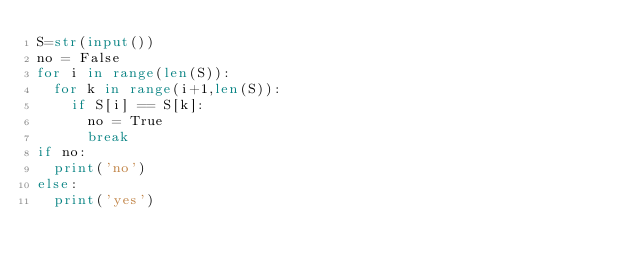<code> <loc_0><loc_0><loc_500><loc_500><_Python_>S=str(input())
no = False
for i in range(len(S)):
  for k in range(i+1,len(S)):
    if S[i] == S[k]:
      no = True
      break
if no:
  print('no')
else:
  print('yes')</code> 